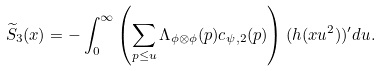<formula> <loc_0><loc_0><loc_500><loc_500>\widetilde { S } _ { 3 } ( x ) = - \int _ { 0 } ^ { \infty } \left ( \sum _ { p \leq u } \Lambda _ { \phi \otimes \phi } ( p ) c _ { \psi , 2 } ( p ) \right ) ( h ( x u ^ { 2 } ) ) ^ { \prime } d u .</formula> 